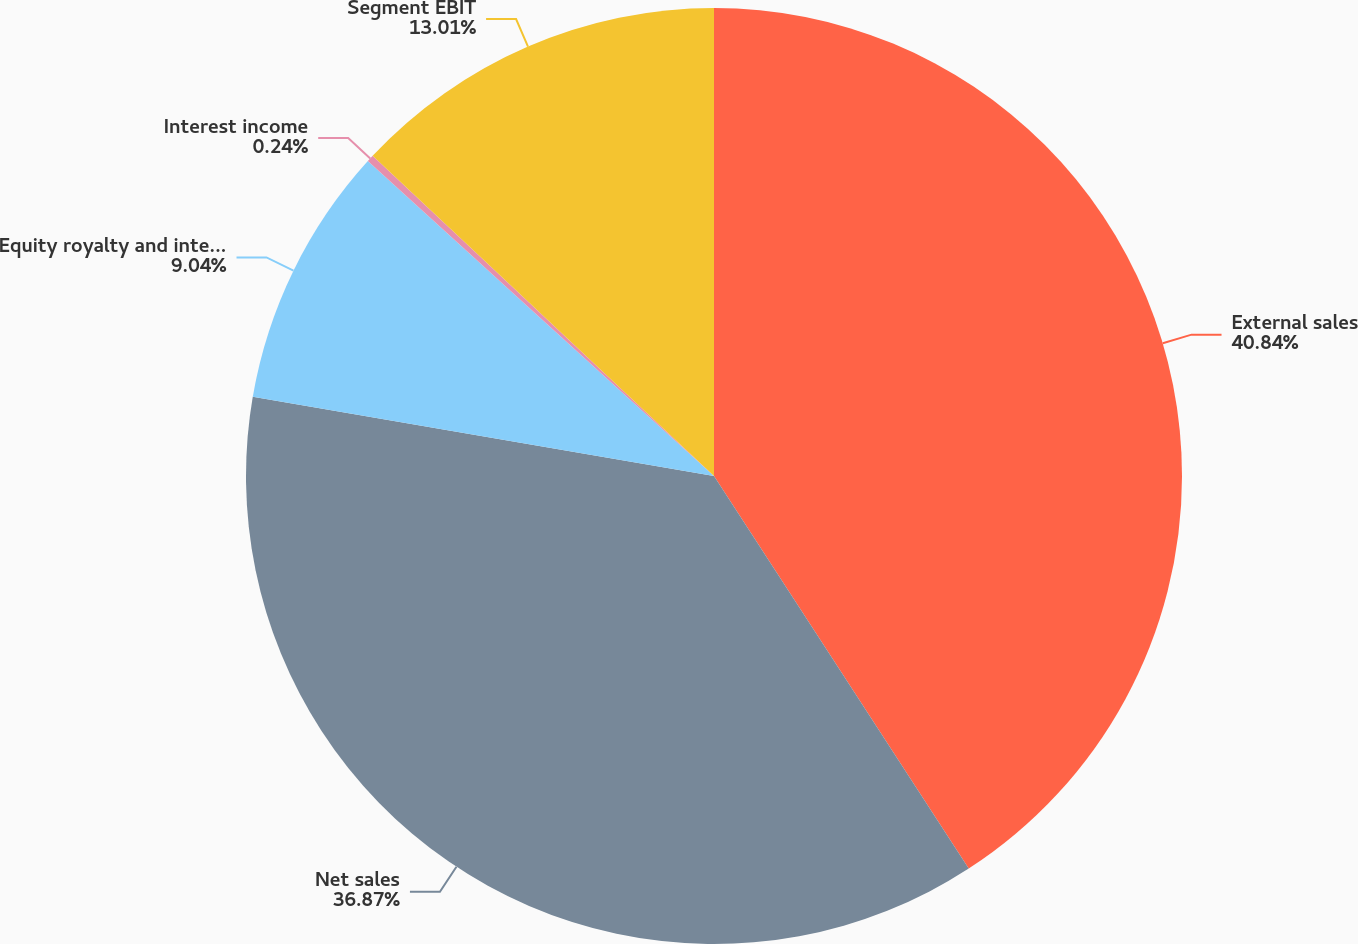<chart> <loc_0><loc_0><loc_500><loc_500><pie_chart><fcel>External sales<fcel>Net sales<fcel>Equity royalty and interest<fcel>Interest income<fcel>Segment EBIT<nl><fcel>40.84%<fcel>36.87%<fcel>9.04%<fcel>0.24%<fcel>13.01%<nl></chart> 